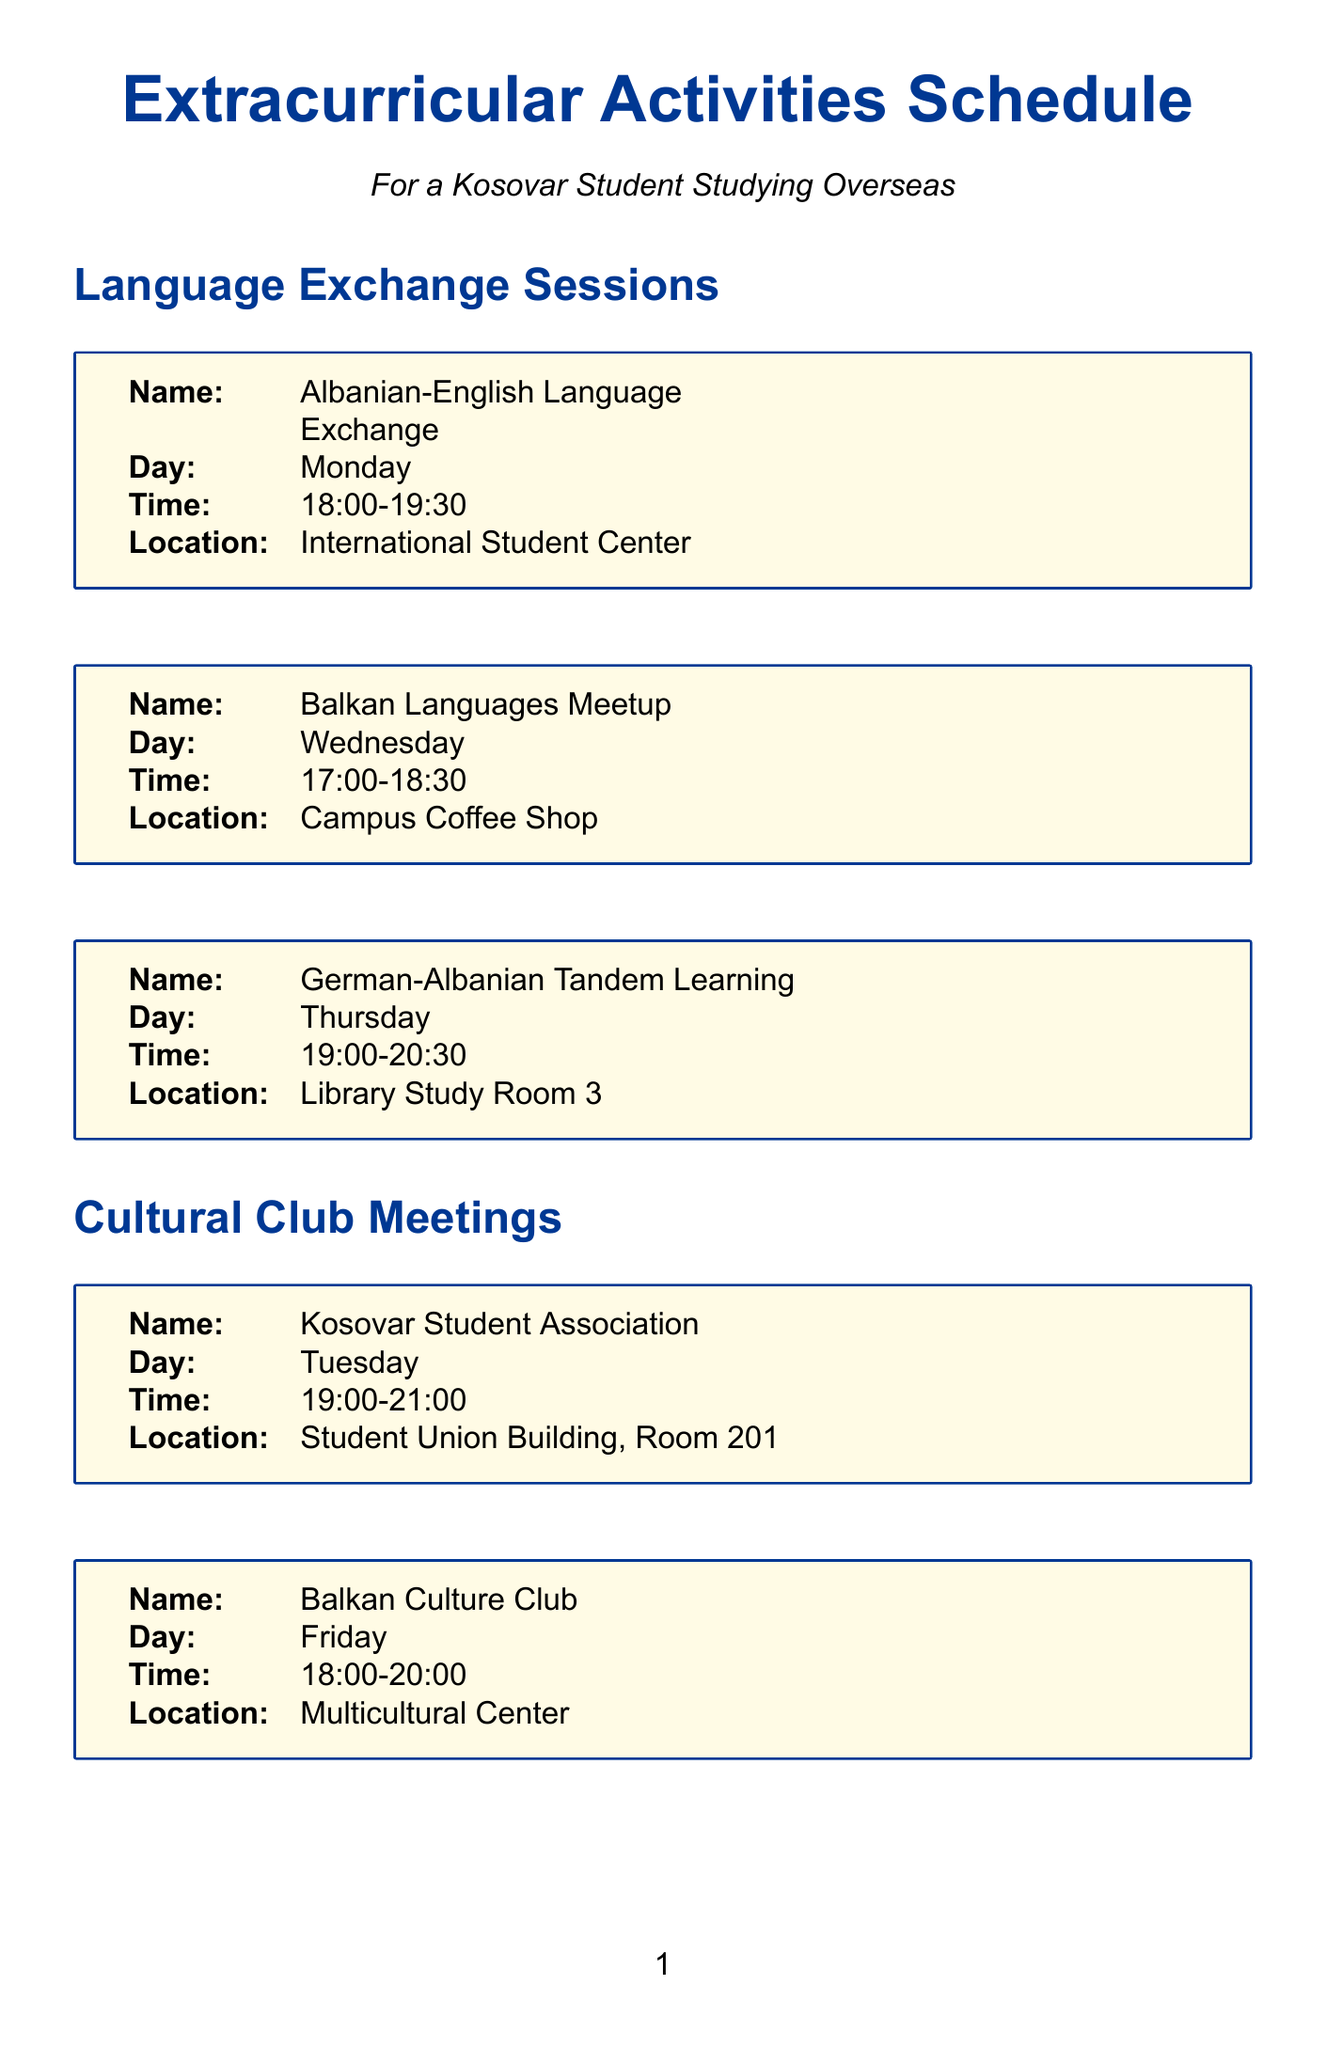What is the location of the Albanian-English Language Exchange? The document states that the Albanian-English Language Exchange is held at the International Student Center.
Answer: International Student Center When is the Balkan Culture Club meeting? The document indicates that the Balkan Culture Club meets on Friday at 18:00 to 20:00.
Answer: Friday What is the date of the International Career Fair? The document specifies that the International Career Fair takes place on October 5.
Answer: October 5 How many days a week is the International Student Writing Center open? The document mentions that the International Student Writing Center operates from Monday to Friday, which is five days.
Answer: Five days What time does the Diwali Celebration start? According to the document, the Diwali Celebration starts at 19:00.
Answer: 19:00 Which event occurs on November 12? The document lists the Diwali Celebration occurring on November 12.
Answer: Diwali Celebration How often does the Albanian Language and Literature Workshop take place? The document states that the Albanian Language and Literature Workshop occurs every second Saturday.
Answer: Every second Saturday Which meeting is specifically for Kosovar students? The document identifies the Kosovar Student Association as the meeting specifically for Kosovar students.
Answer: Kosovar Student Association What is the name of the event happening on September 15? The document specifies that the event on September 15 is the Global Food Festival.
Answer: Global Food Festival 